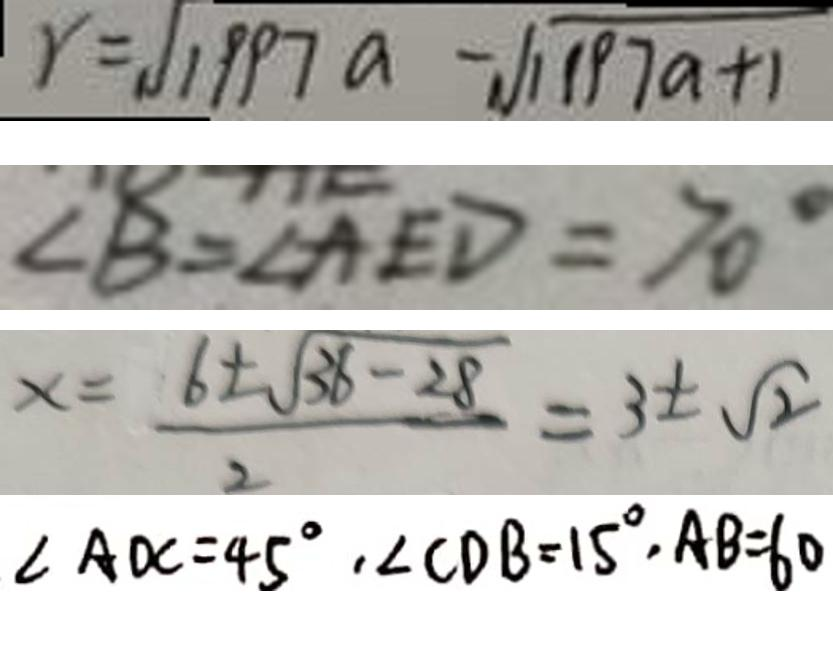<formula> <loc_0><loc_0><loc_500><loc_500>r = \sqrt { 1 9 9 7 a } - \sqrt { 1 1 9 7 a + 1 } 
 \angle B = \angle A E D = 7 0 ^ { \circ } 
 x = \frac { 6 \pm \sqrt { 3 6 } - 2 8 } { 2 } = 3 \pm \sqrt { 2 } 
 \angle A d C = 4 5 ^ { \circ } , \angle C D B = 1 5 ^ { \circ } , A B = 6 0</formula> 